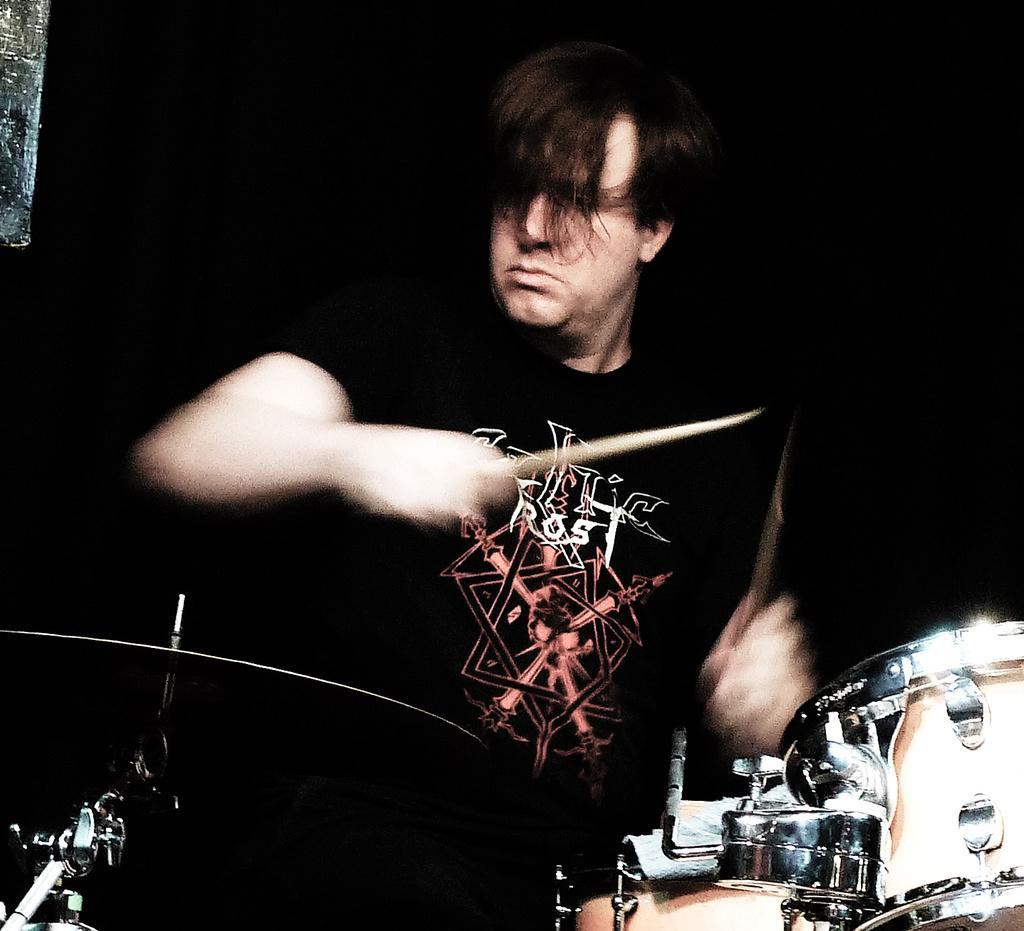How would you summarize this image in a sentence or two? In this image we can see a person holding sticks, in front of him there are some musical instruments and other objects, we can see the background is dark. 